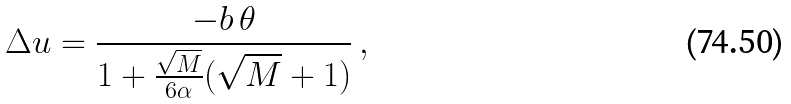<formula> <loc_0><loc_0><loc_500><loc_500>\Delta u = \frac { - b \, \theta } { 1 + \frac { \sqrt { M } } { 6 \alpha } ( \sqrt { M } + 1 ) } \, ,</formula> 